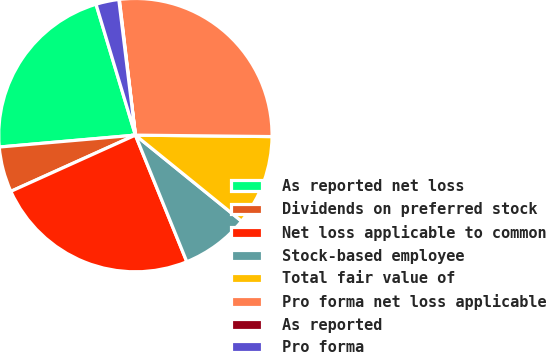Convert chart to OTSL. <chart><loc_0><loc_0><loc_500><loc_500><pie_chart><fcel>As reported net loss<fcel>Dividends on preferred stock<fcel>Net loss applicable to common<fcel>Stock-based employee<fcel>Total fair value of<fcel>Pro forma net loss applicable<fcel>As reported<fcel>Pro forma<nl><fcel>21.74%<fcel>5.36%<fcel>24.39%<fcel>8.02%<fcel>10.67%<fcel>27.05%<fcel>0.06%<fcel>2.71%<nl></chart> 